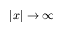Convert formula to latex. <formula><loc_0><loc_0><loc_500><loc_500>\left | x \right | \to \infty</formula> 